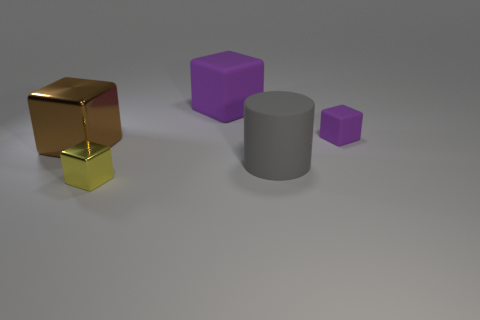Subtract all blue cylinders. How many purple cubes are left? 2 Add 1 tiny purple matte blocks. How many objects exist? 6 Subtract all purple blocks. How many blocks are left? 2 Subtract all blocks. How many objects are left? 1 Subtract all gray blocks. Subtract all brown spheres. How many blocks are left? 4 Subtract all blocks. Subtract all big brown metallic blocks. How many objects are left? 0 Add 3 large gray cylinders. How many large gray cylinders are left? 4 Add 1 big gray objects. How many big gray objects exist? 2 Subtract 0 brown balls. How many objects are left? 5 Subtract 1 cylinders. How many cylinders are left? 0 